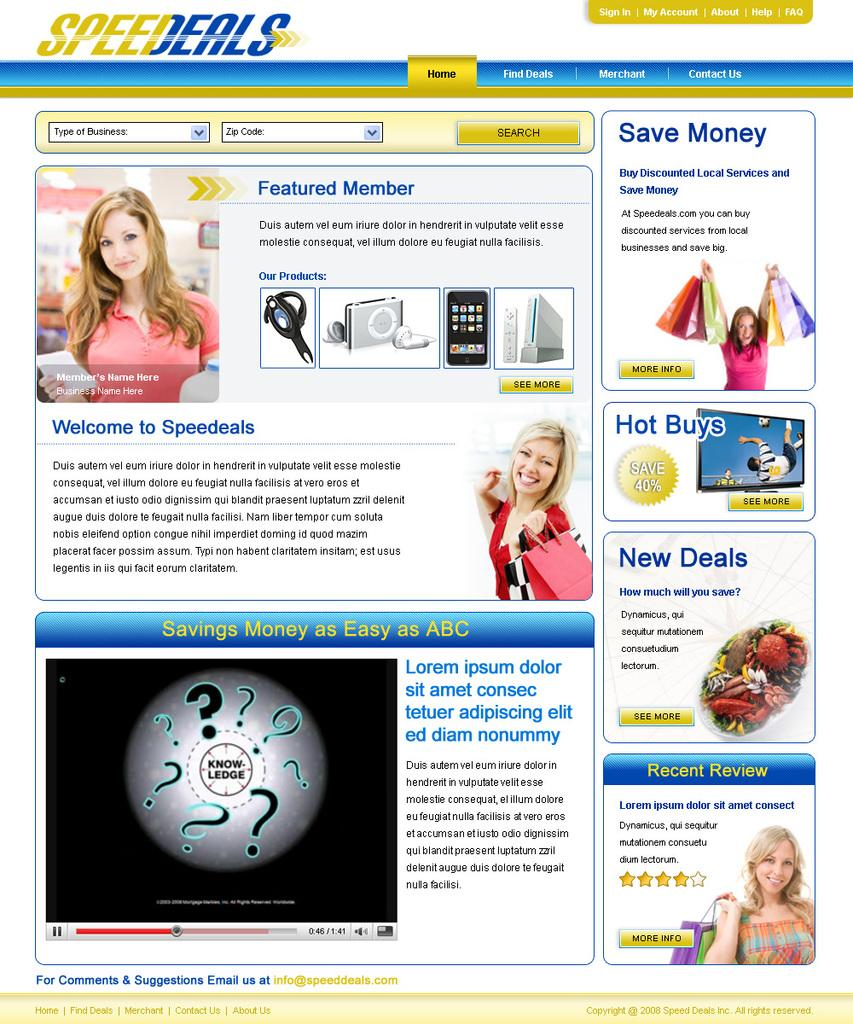What is the main subject of the image? There is an advertisement in the center of the image. What type of comparison can be seen between the two products in the advertisement? There is no comparison between two products in the advertisement, as only one subject is mentioned in the provided fact. 